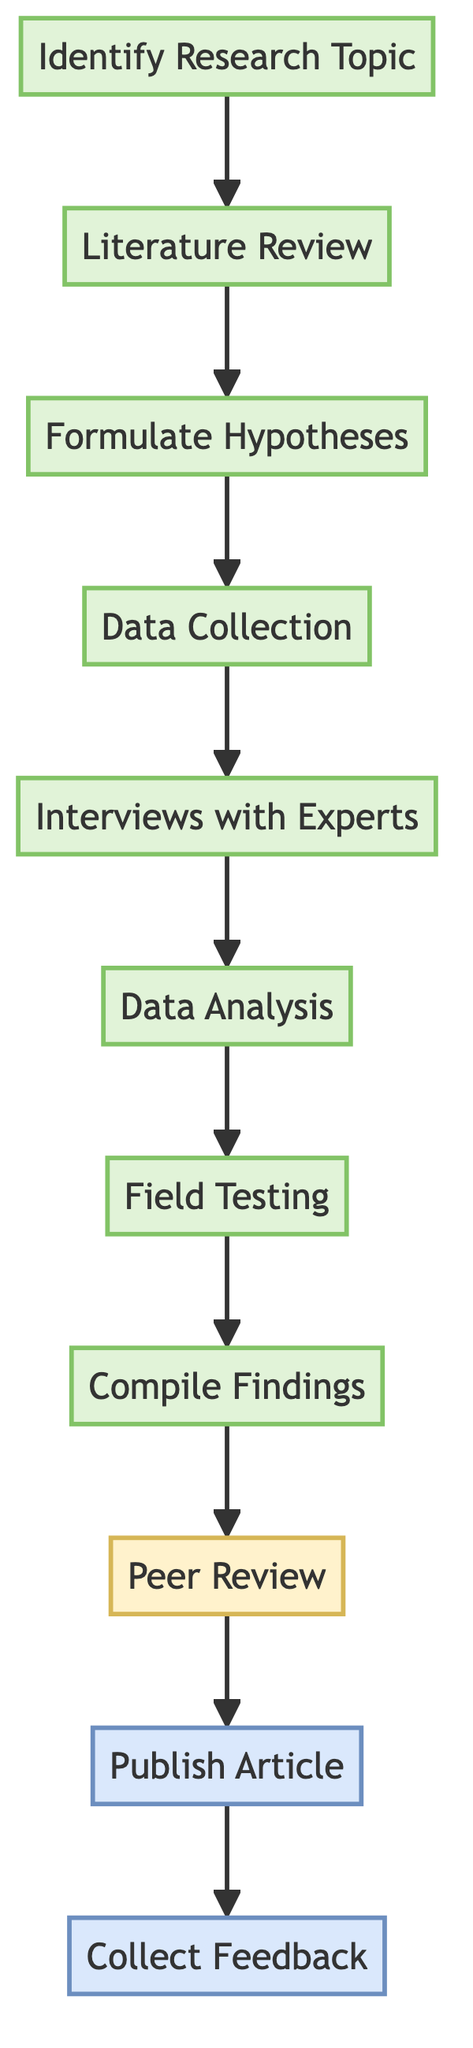What is the first step in the process? The first step in the process is listed as "Identify Research Topic," marking the beginning of the analysis on automotive safety features.
Answer: Identify Research Topic How many total steps are in the flowchart? By counting each element from "Identify Research Topic" to "Collect Feedback," there are ten steps represented in the flowchart.
Answer: Ten Which step follows "Data Collection"? In the diagram, "Interviews with Experts" directly follows "Data Collection," indicating the next action to take.
Answer: Interviews with Experts What type of analysis is performed after collecting data? The step that comes next after collecting data is "Data Analysis," highlighting the need for evaluation of the gathered information.
Answer: Data Analysis Which step comes before the "Publish Article"? The step preceding "Publish Article" is "Peer Review," demonstrating the importance of validation before publication.
Answer: Peer Review What color represents the review steps in the diagram? The color associated with review steps is yellow (noted by the color code #fff2cc), which visually differentiates these steps from other types in the diagram.
Answer: Yellow What is the last step in the process? The final step documented in the flowchart is "Collect Feedback," indicating the closure of the analysis process with reader engagement.
Answer: Collect Feedback Which step involves gaining insights from industry experts? The step dedicated to gathering insights from industry professionals is "Interviews with Experts," highlighting its significance in the analysis process.
Answer: Interviews with Experts 